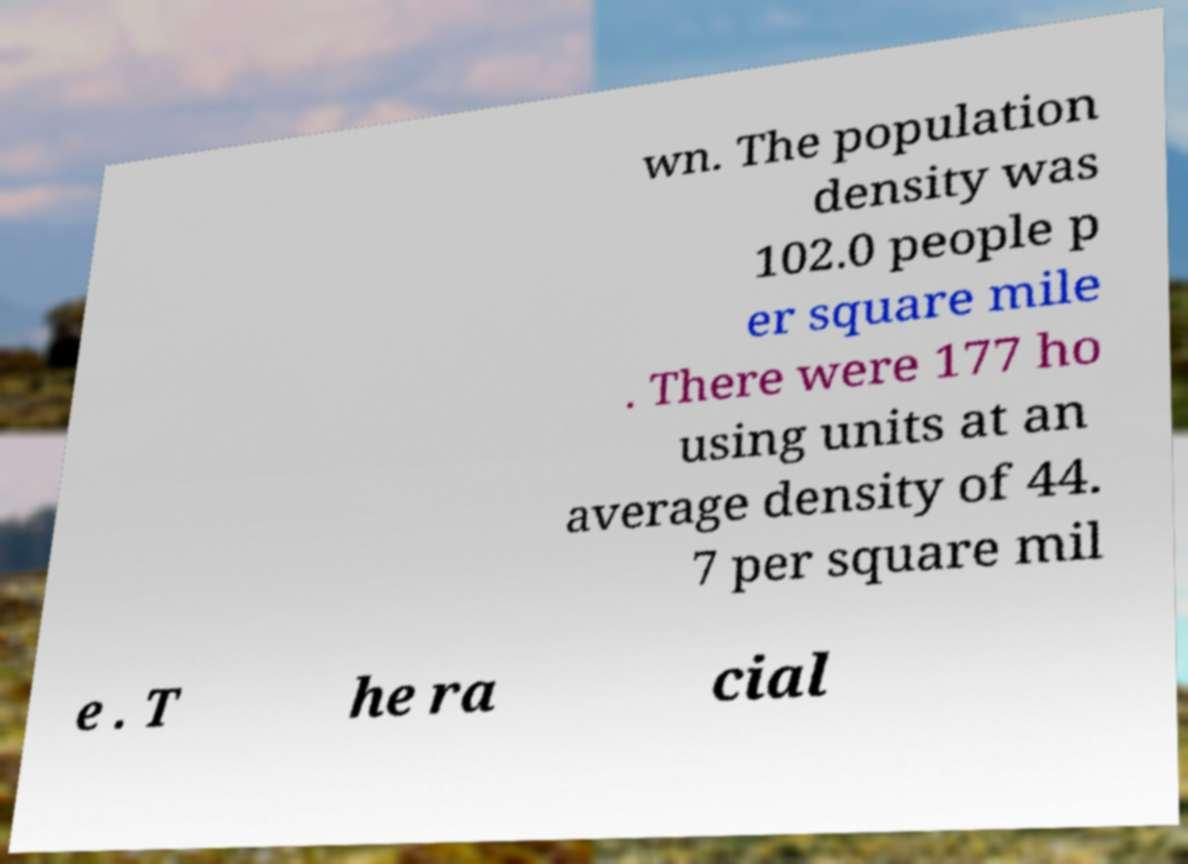Please identify and transcribe the text found in this image. wn. The population density was 102.0 people p er square mile . There were 177 ho using units at an average density of 44. 7 per square mil e . T he ra cial 